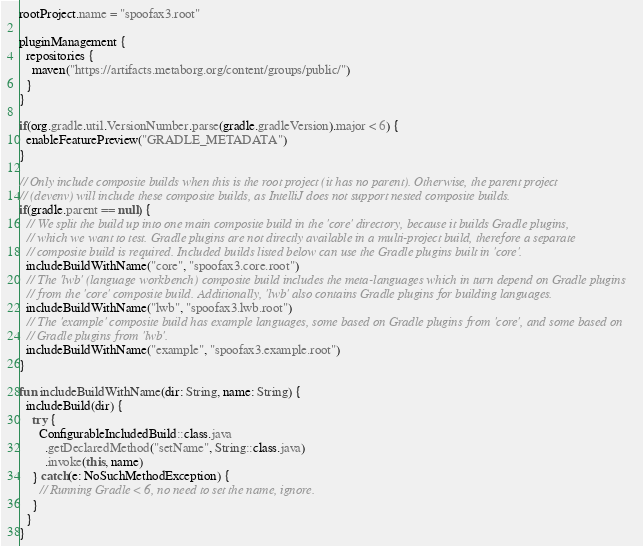Convert code to text. <code><loc_0><loc_0><loc_500><loc_500><_Kotlin_>rootProject.name = "spoofax3.root"

pluginManagement {
  repositories {
    maven("https://artifacts.metaborg.org/content/groups/public/")
  }
}

if(org.gradle.util.VersionNumber.parse(gradle.gradleVersion).major < 6) {
  enableFeaturePreview("GRADLE_METADATA")
}

// Only include composite builds when this is the root project (it has no parent). Otherwise, the parent project
// (devenv) will include these composite builds, as IntelliJ does not support nested composite builds.
if(gradle.parent == null) {
  // We split the build up into one main composite build in the 'core' directory, because it builds Gradle plugins,
  // which we want to test. Gradle plugins are not directly available in a multi-project build, therefore a separate
  // composite build is required. Included builds listed below can use the Gradle plugins built in 'core'.
  includeBuildWithName("core", "spoofax3.core.root")
  // The 'lwb' (language workbench) composite build includes the meta-languages which in turn depend on Gradle plugins
  // from the 'core' composite build. Additionally, 'lwb' also contains Gradle plugins for building languages.
  includeBuildWithName("lwb", "spoofax3.lwb.root")
  // The 'example' composite build has example languages, some based on Gradle plugins from 'core', and some based on
  // Gradle plugins from 'lwb'.
  includeBuildWithName("example", "spoofax3.example.root")
}

fun includeBuildWithName(dir: String, name: String) {
  includeBuild(dir) {
    try {
      ConfigurableIncludedBuild::class.java
        .getDeclaredMethod("setName", String::class.java)
        .invoke(this, name)
    } catch(e: NoSuchMethodException) {
      // Running Gradle < 6, no need to set the name, ignore.
    }
  }
}
</code> 